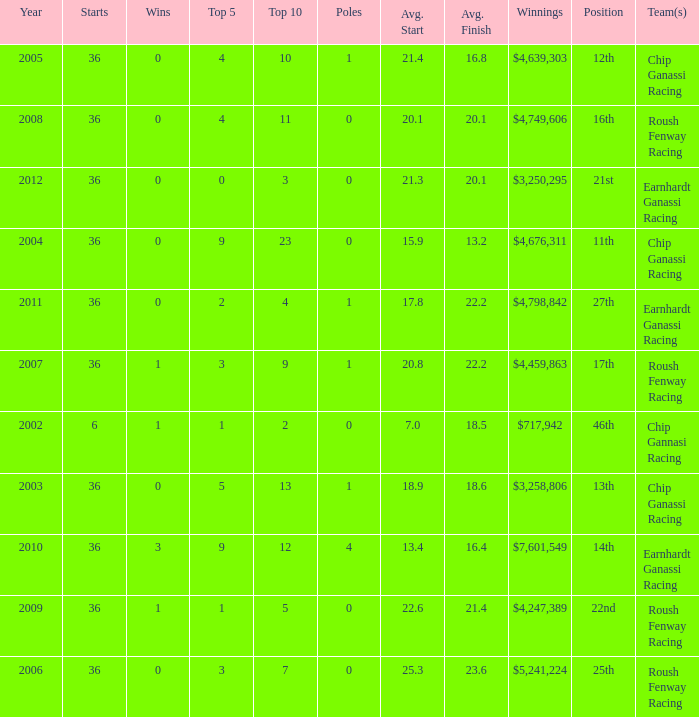Identify the poles at the 25th spot. 0.0. 